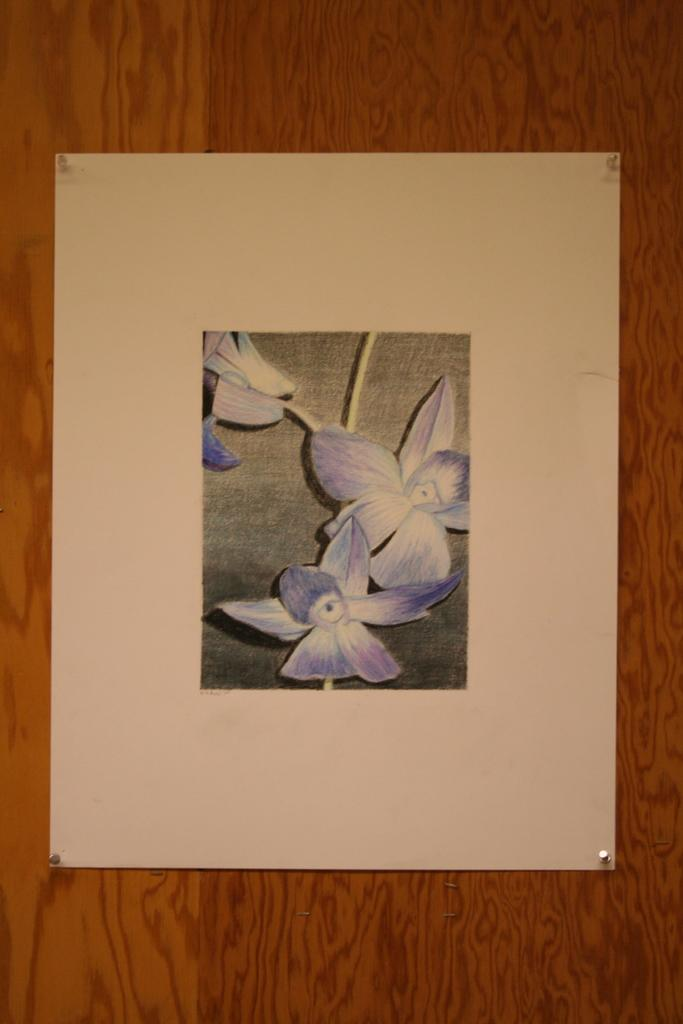What type of material is used for the wall in the image? There is a wooden wall in the image. What is depicted on the paper in the image? The paper has a painting of flowers in the image. What additional feature can be seen on the paper? The paper has needles on its four sides. What type of vegetable is being cooked in the pan in the image? There is no pan or vegetable present in the image. Why is the person in the image crying? There is no person or crying sound can be heard in the image. 